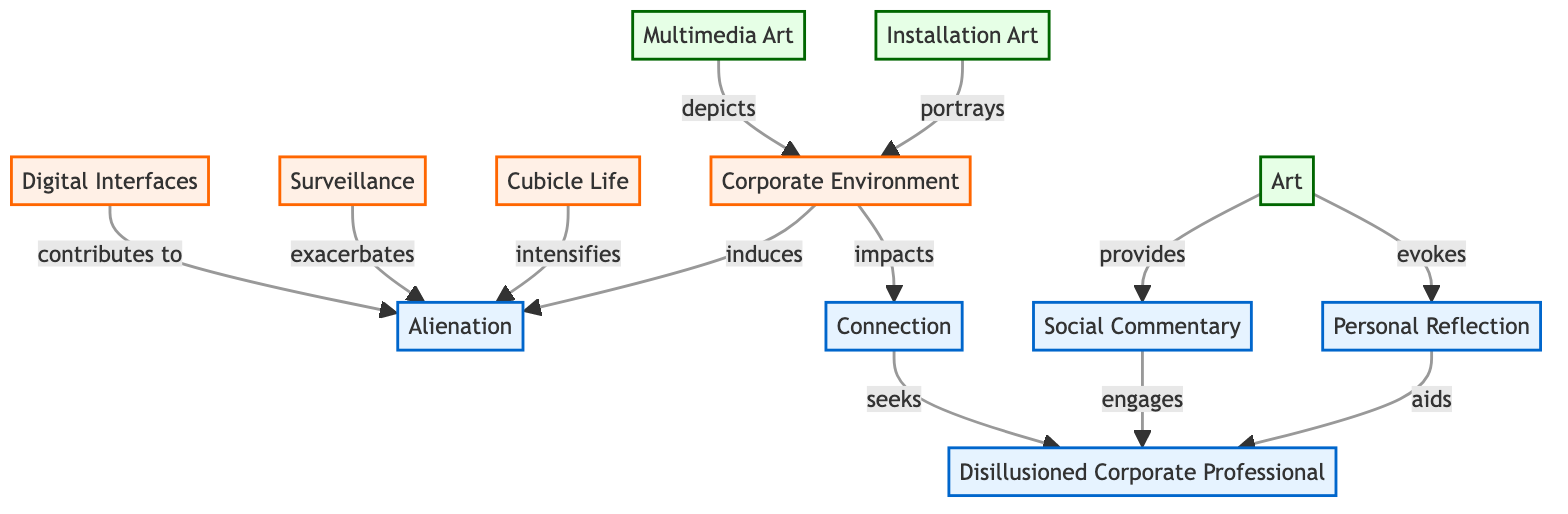What is the total number of nodes in the diagram? There are 11 distinct nodes listed: Alienation, Connection, Corporate Environment, Cubicle Life, Surveillance, Digital Interfaces, Art, Installation Art, Multimedia Art, Personal Reflection, and Social Commentary.
Answer: 11 Which node induces alienation? The node "Corporate Environment" is connected to "Alienation" with the label "induces," indicating it causes or contributes to feelings of alienation.
Answer: Corporate Environment How many edges connect to the node 'Alienation'? The node "Alienation" has a total of 4 edges connecting to it: from "Corporate Environment," "Cubicle Life," "Surveillance," and "Digital Interfaces."
Answer: 4 Which type of art evokes personal reflection? The diagram indicates that "Art" is connected to "Personal Reflection" with the label "evokes," meaning it stirs or inspires personal thoughts and feelings.
Answer: Art What relationship does installation art have with the corporate environment? "Installation Art" is connected to "Corporate Environment" with the label "portrays," suggesting it visually represents aspects of corporate life.
Answer: portrays How does the social commentary engage the disillusioned corporate professional? The diagram shows that "Social Commentary" is linked to "Disillusioned Corporate Professional" with the label "engages," indicating it invites or captures the attention of individuals feeling disillusioned by corporate culture.
Answer: engages What contributes to alienation according to the diagram? The diagram lists "Digital Interfaces" as having a connection to "Alienation" with the label "contributes to," indicating it plays a role in fostering feelings of isolation.
Answer: Digital Interfaces What do disillusioned corporate professionals seek? The node "Connection" connects to "Disillusioned Corporate Professional" with the label "seeks," suggesting that these individuals are looking for meaningful relationships or interactions.
Answer: seeks Which node intensifies alienation? The edge between "Cubicle Life" and "Alienation" is labeled "intensifies," indicating that life in cubicles heightens feelings of alienation.
Answer: Cubicle Life 